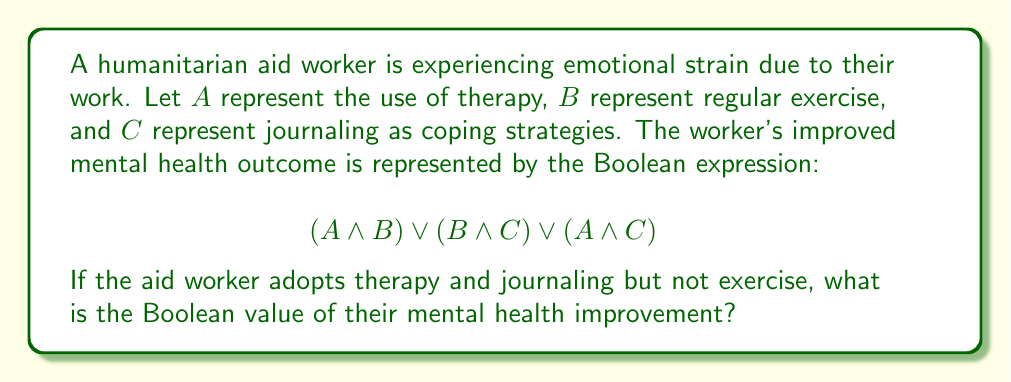Help me with this question. Let's approach this step-by-step:

1) We are given that the worker adopts therapy and journaling, but not exercise. This means:
   $A = 1$ (therapy is used)
   $B = 0$ (exercise is not used)
   $C = 1$ (journaling is used)

2) Let's substitute these values into our Boolean expression:
   $$(A \land B) \lor (B \land C) \lor (A \land C)$$
   $$(1 \land 0) \lor (0 \land 1) \lor (1 \land 1)$$

3) Now, let's evaluate each term:
   - $(1 \land 0) = 0$ (therapy AND no exercise = false)
   - $(0 \land 1) = 0$ (no exercise AND journaling = false)
   - $(1 \land 1) = 1$ (therapy AND journaling = true)

4) Our expression now looks like:
   $$0 \lor 0 \lor 1$$

5) In Boolean algebra, $\lor$ (OR) returns true if at least one of its inputs is true. Since we have a 1 in our expression, the result will be true.

6) Therefore, the final result is 1 (true).
Answer: 1 